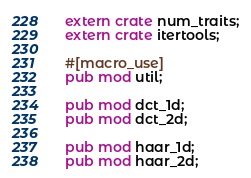Convert code to text. <code><loc_0><loc_0><loc_500><loc_500><_Rust_>extern crate num_traits;
extern crate itertools;

#[macro_use]
pub mod util;

pub mod dct_1d;
pub mod dct_2d;

pub mod haar_1d;
pub mod haar_2d;</code> 